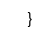<code> <loc_0><loc_0><loc_500><loc_500><_Kotlin_>
}
</code> 